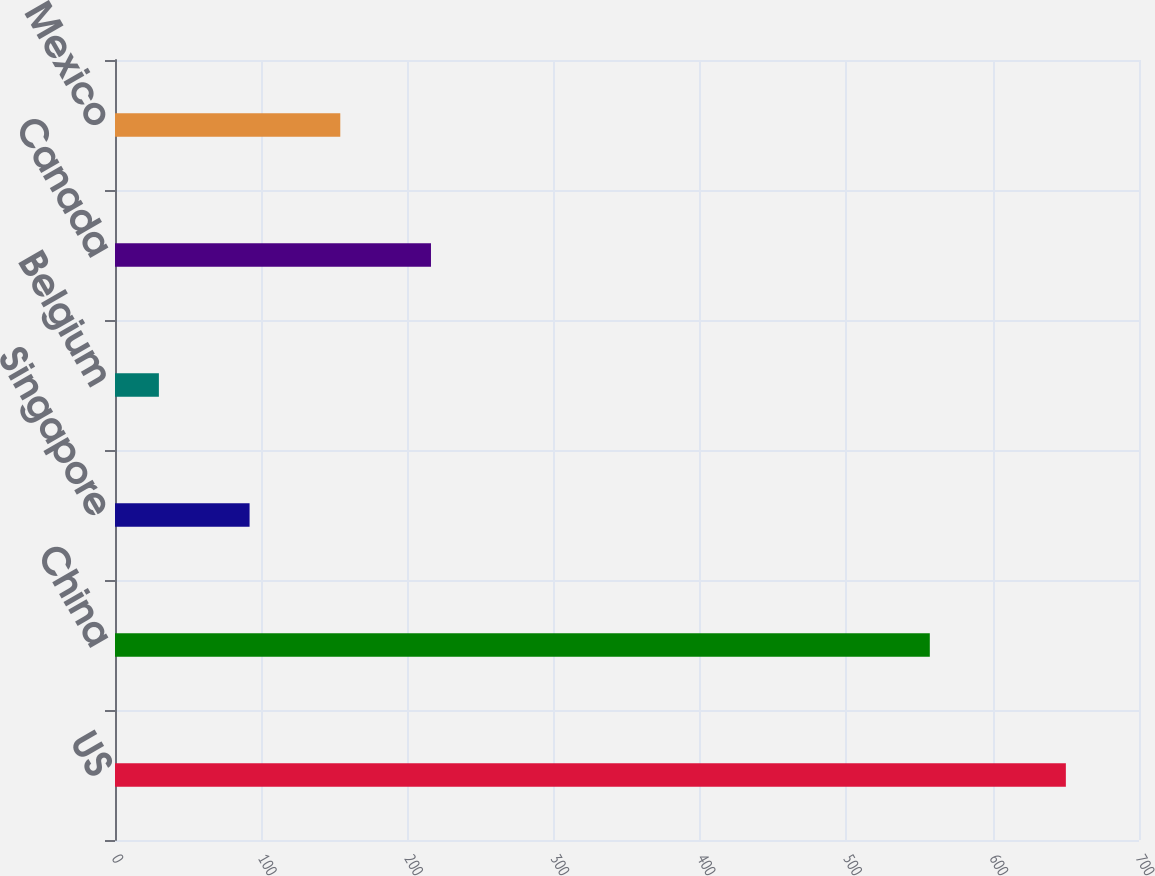Convert chart. <chart><loc_0><loc_0><loc_500><loc_500><bar_chart><fcel>US<fcel>China<fcel>Singapore<fcel>Belgium<fcel>Canada<fcel>Mexico<nl><fcel>650<fcel>557<fcel>92<fcel>30<fcel>216<fcel>154<nl></chart> 